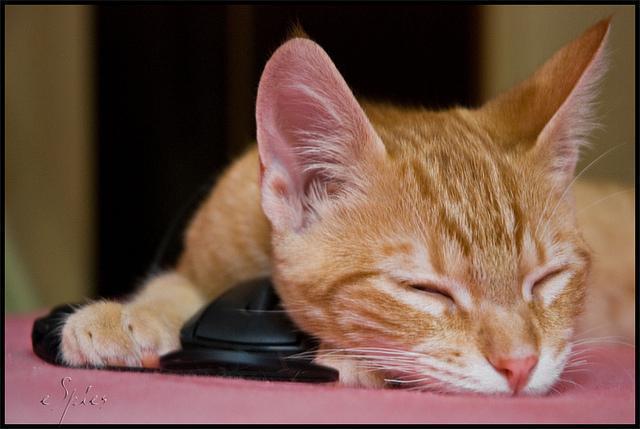How many cats can be seen?
Give a very brief answer. 1. How many mice are visible?
Give a very brief answer. 1. 